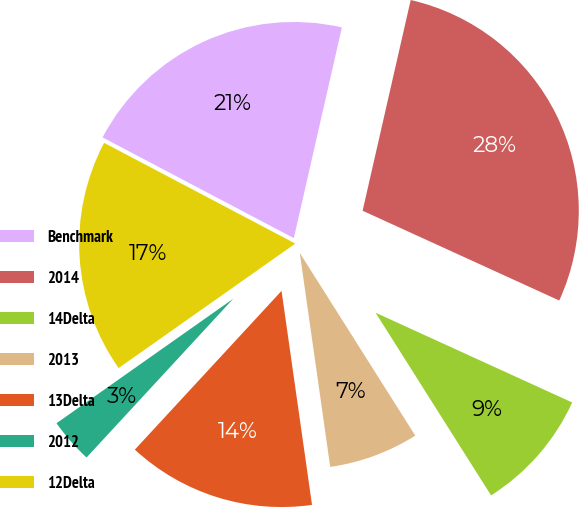<chart> <loc_0><loc_0><loc_500><loc_500><pie_chart><fcel>Benchmark<fcel>2014<fcel>14Delta<fcel>2013<fcel>13Delta<fcel>2012<fcel>12Delta<nl><fcel>20.85%<fcel>28.24%<fcel>9.21%<fcel>6.72%<fcel>14.12%<fcel>3.36%<fcel>17.48%<nl></chart> 